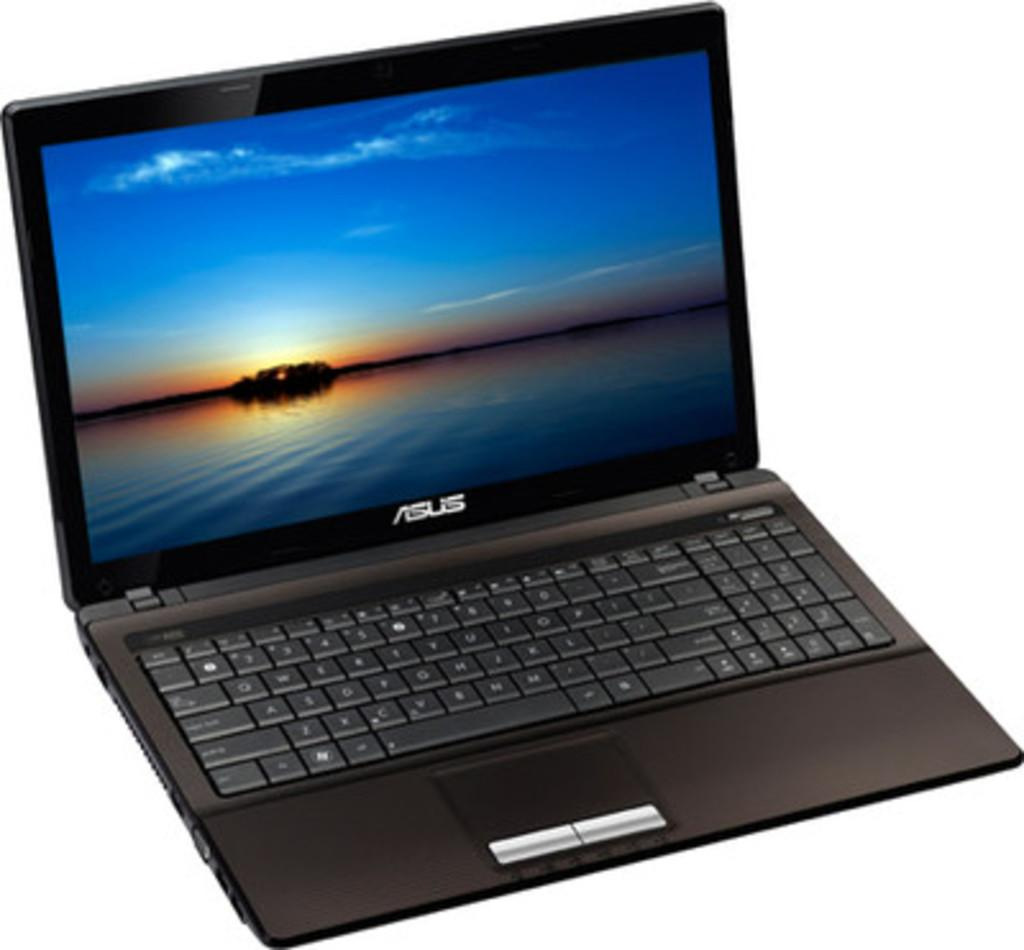<image>
Relay a brief, clear account of the picture shown. A black Asus laptop is open to a blue sky screensaver. 